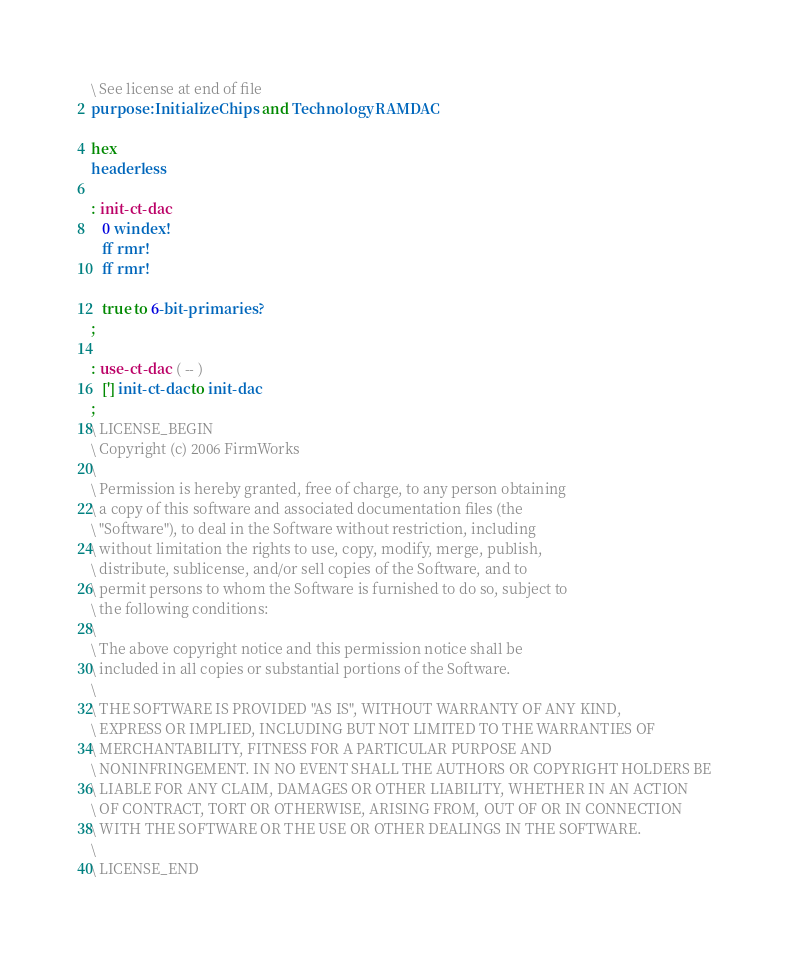<code> <loc_0><loc_0><loc_500><loc_500><_Forth_>\ See license at end of file
purpose: Initialize Chips and Technology RAMDAC

hex
headerless

: init-ct-dac
   0 windex!
   ff rmr!
   ff rmr!

   true to 6-bit-primaries?
;

: use-ct-dac  ( -- )
   ['] init-ct-dac to init-dac
;
\ LICENSE_BEGIN
\ Copyright (c) 2006 FirmWorks
\ 
\ Permission is hereby granted, free of charge, to any person obtaining
\ a copy of this software and associated documentation files (the
\ "Software"), to deal in the Software without restriction, including
\ without limitation the rights to use, copy, modify, merge, publish,
\ distribute, sublicense, and/or sell copies of the Software, and to
\ permit persons to whom the Software is furnished to do so, subject to
\ the following conditions:
\ 
\ The above copyright notice and this permission notice shall be
\ included in all copies or substantial portions of the Software.
\ 
\ THE SOFTWARE IS PROVIDED "AS IS", WITHOUT WARRANTY OF ANY KIND,
\ EXPRESS OR IMPLIED, INCLUDING BUT NOT LIMITED TO THE WARRANTIES OF
\ MERCHANTABILITY, FITNESS FOR A PARTICULAR PURPOSE AND
\ NONINFRINGEMENT. IN NO EVENT SHALL THE AUTHORS OR COPYRIGHT HOLDERS BE
\ LIABLE FOR ANY CLAIM, DAMAGES OR OTHER LIABILITY, WHETHER IN AN ACTION
\ OF CONTRACT, TORT OR OTHERWISE, ARISING FROM, OUT OF OR IN CONNECTION
\ WITH THE SOFTWARE OR THE USE OR OTHER DEALINGS IN THE SOFTWARE.
\
\ LICENSE_END
</code> 